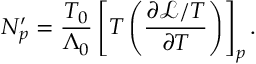<formula> <loc_0><loc_0><loc_500><loc_500>N _ { p } ^ { \prime } = \frac { T _ { 0 } } { \Lambda _ { 0 } } \left [ T \left ( \frac { \partial \mathcal { L } / T } { \partial T } \right ) \right ] _ { p } .</formula> 